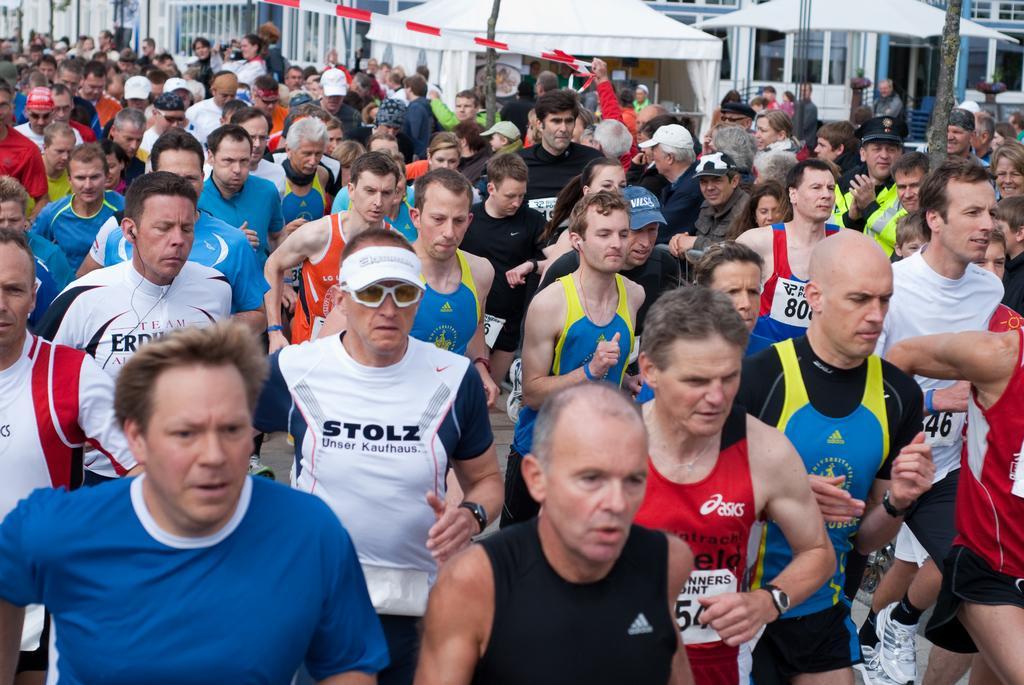How would you summarize this image in a sentence or two? In this image there are group of people participating in running race,there are few audience,tent,there is a building. 